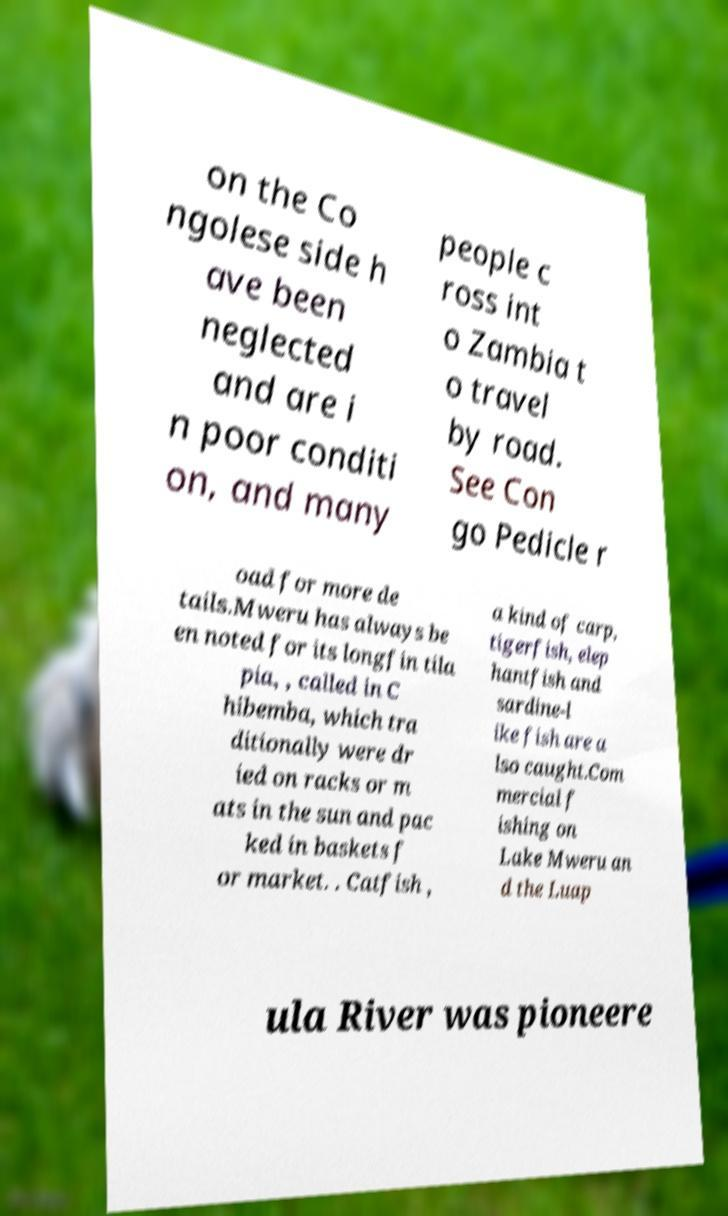Please identify and transcribe the text found in this image. on the Co ngolese side h ave been neglected and are i n poor conditi on, and many people c ross int o Zambia t o travel by road. See Con go Pedicle r oad for more de tails.Mweru has always be en noted for its longfin tila pia, , called in C hibemba, which tra ditionally were dr ied on racks or m ats in the sun and pac ked in baskets f or market. . Catfish , a kind of carp, tigerfish, elep hantfish and sardine-l ike fish are a lso caught.Com mercial f ishing on Lake Mweru an d the Luap ula River was pioneere 